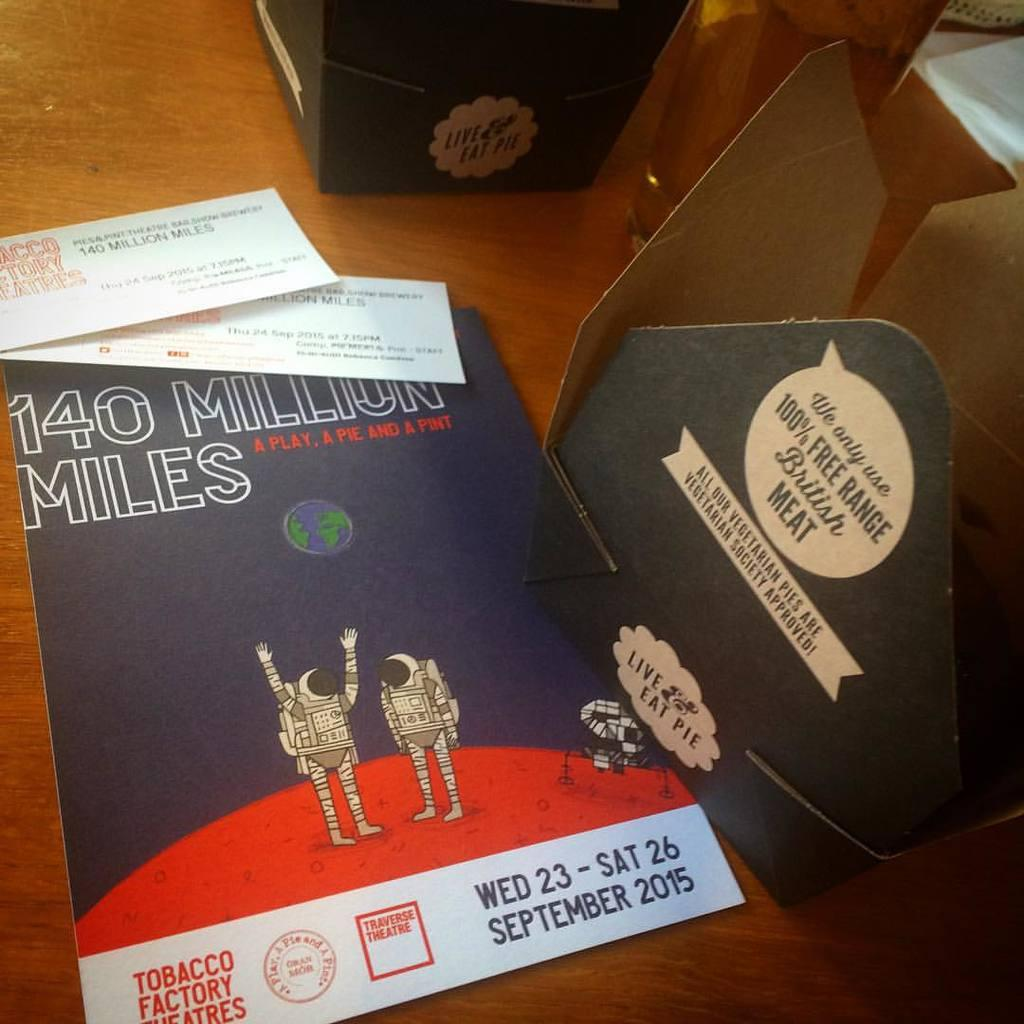What is on the wooden surface in the image? There are papers and boxes on the wooden surface. Can you describe the unspecified "things" on the wooden surface? Unfortunately, the provided facts do not specify what these "things" are. How many items are on the wooden surface in total? There are papers, boxes, and unspecified "things," but the exact number of "things" is not mentioned. What type of copper material is present on the wooden surface in the image? There is no mention of copper or any copper-related materials in the provided facts. 